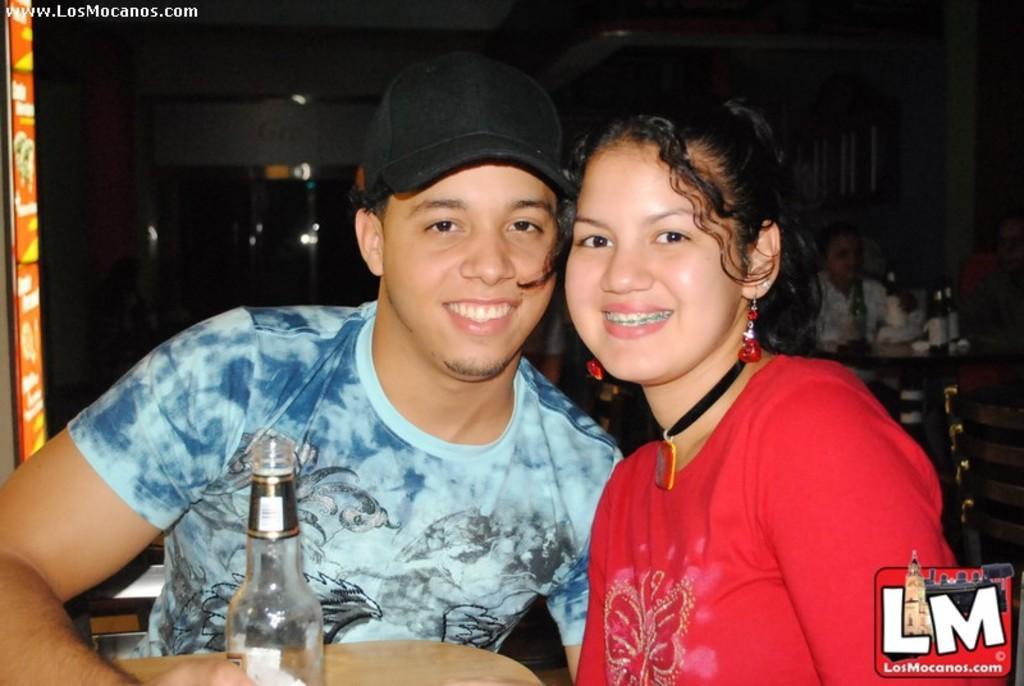In one or two sentences, can you explain what this image depicts? This image looks like it is clicked inside a restaurant. There are two persons in the front, in the image. Man and a woman. The man is wearing blue t-shirt and the woman is wearing red shirt. To the right, there are chairs and table. In the background, there is wall and door. 